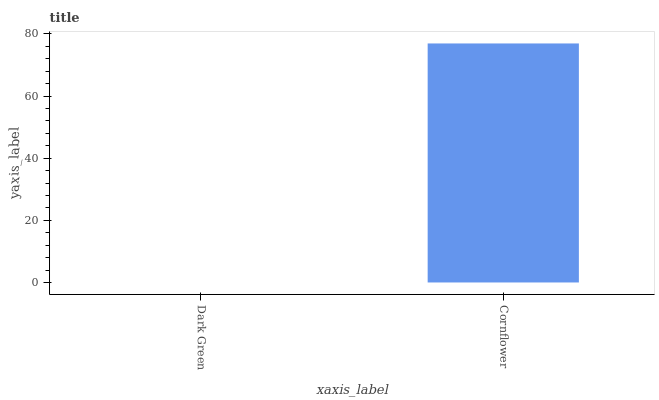Is Dark Green the minimum?
Answer yes or no. Yes. Is Cornflower the maximum?
Answer yes or no. Yes. Is Cornflower the minimum?
Answer yes or no. No. Is Cornflower greater than Dark Green?
Answer yes or no. Yes. Is Dark Green less than Cornflower?
Answer yes or no. Yes. Is Dark Green greater than Cornflower?
Answer yes or no. No. Is Cornflower less than Dark Green?
Answer yes or no. No. Is Cornflower the high median?
Answer yes or no. Yes. Is Dark Green the low median?
Answer yes or no. Yes. Is Dark Green the high median?
Answer yes or no. No. Is Cornflower the low median?
Answer yes or no. No. 